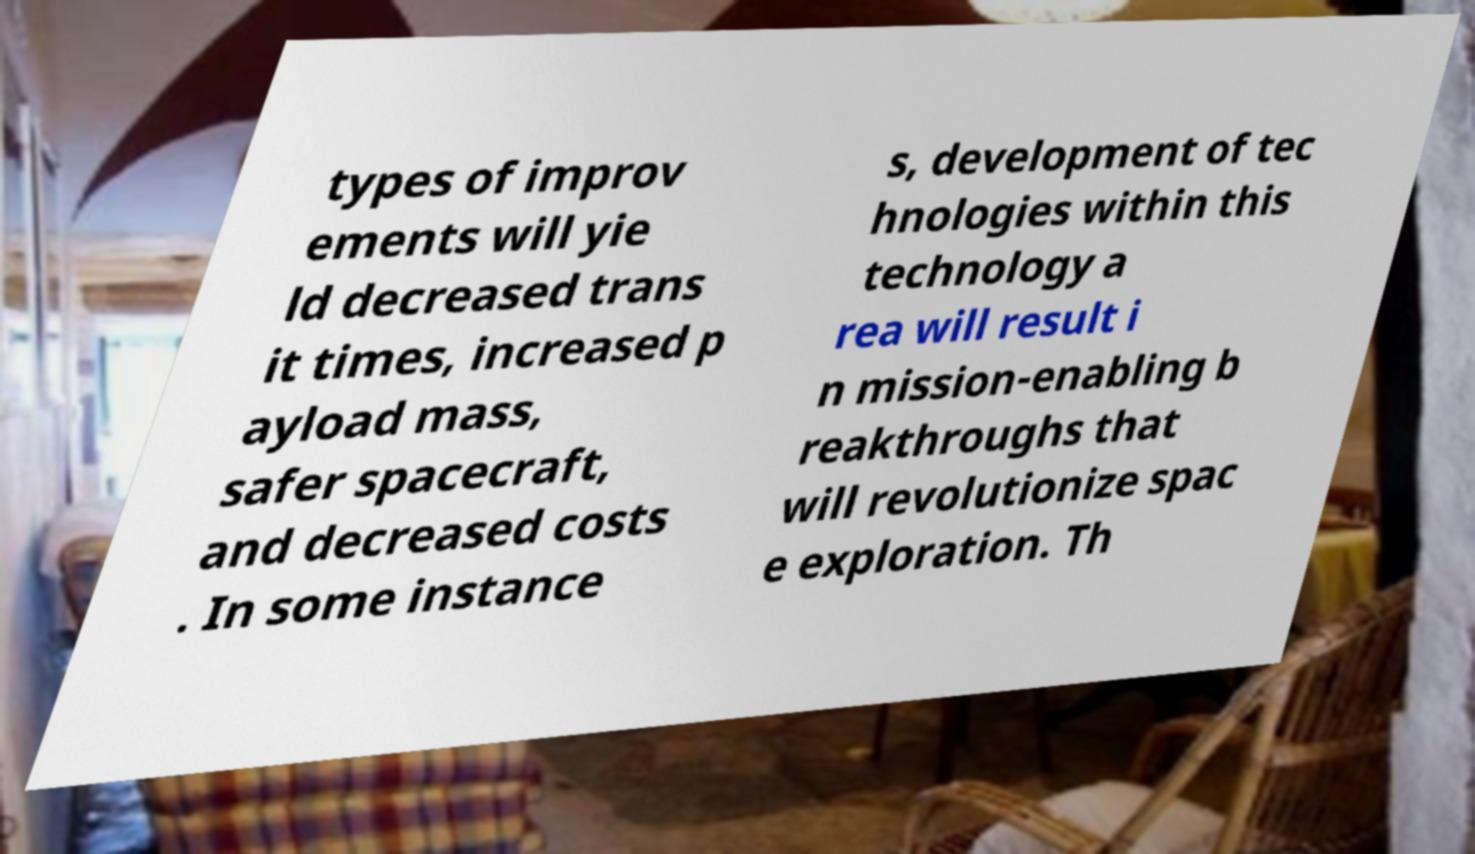Please identify and transcribe the text found in this image. types of improv ements will yie ld decreased trans it times, increased p ayload mass, safer spacecraft, and decreased costs . In some instance s, development of tec hnologies within this technology a rea will result i n mission-enabling b reakthroughs that will revolutionize spac e exploration. Th 